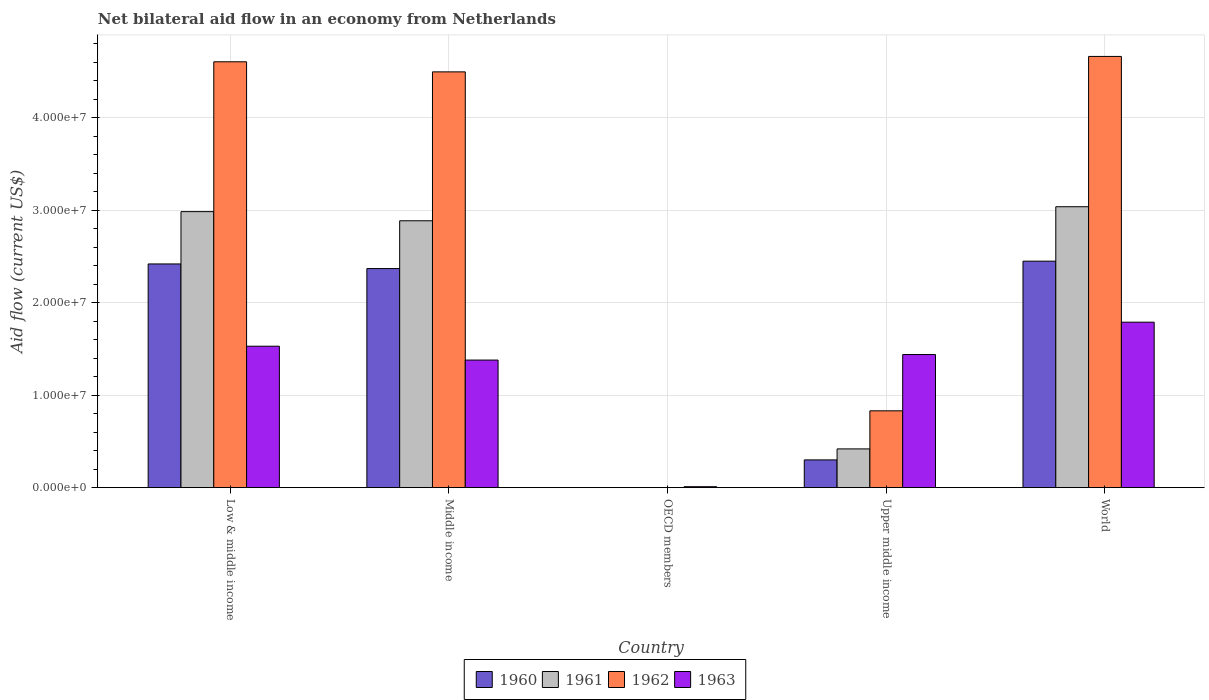How many bars are there on the 4th tick from the left?
Keep it short and to the point. 4. How many bars are there on the 4th tick from the right?
Ensure brevity in your answer.  4. What is the label of the 1st group of bars from the left?
Make the answer very short. Low & middle income. In how many cases, is the number of bars for a given country not equal to the number of legend labels?
Your answer should be compact. 1. What is the net bilateral aid flow in 1961 in Middle income?
Provide a succinct answer. 2.89e+07. Across all countries, what is the maximum net bilateral aid flow in 1960?
Provide a succinct answer. 2.45e+07. What is the total net bilateral aid flow in 1960 in the graph?
Offer a very short reply. 7.54e+07. What is the difference between the net bilateral aid flow in 1963 in OECD members and that in World?
Your answer should be very brief. -1.78e+07. What is the difference between the net bilateral aid flow in 1961 in Low & middle income and the net bilateral aid flow in 1960 in Upper middle income?
Your answer should be compact. 2.69e+07. What is the average net bilateral aid flow in 1960 per country?
Your response must be concise. 1.51e+07. What is the difference between the net bilateral aid flow of/in 1962 and net bilateral aid flow of/in 1961 in Low & middle income?
Your response must be concise. 1.62e+07. In how many countries, is the net bilateral aid flow in 1963 greater than 40000000 US$?
Provide a short and direct response. 0. What is the ratio of the net bilateral aid flow in 1962 in Middle income to that in World?
Give a very brief answer. 0.96. Is the net bilateral aid flow in 1961 in Low & middle income less than that in Upper middle income?
Give a very brief answer. No. What is the difference between the highest and the second highest net bilateral aid flow in 1961?
Keep it short and to the point. 1.52e+06. What is the difference between the highest and the lowest net bilateral aid flow in 1961?
Keep it short and to the point. 3.04e+07. Is it the case that in every country, the sum of the net bilateral aid flow in 1961 and net bilateral aid flow in 1962 is greater than the net bilateral aid flow in 1963?
Make the answer very short. No. How many bars are there?
Ensure brevity in your answer.  17. How many countries are there in the graph?
Keep it short and to the point. 5. What is the difference between two consecutive major ticks on the Y-axis?
Give a very brief answer. 1.00e+07. Does the graph contain any zero values?
Provide a succinct answer. Yes. How many legend labels are there?
Provide a succinct answer. 4. What is the title of the graph?
Ensure brevity in your answer.  Net bilateral aid flow in an economy from Netherlands. What is the label or title of the Y-axis?
Give a very brief answer. Aid flow (current US$). What is the Aid flow (current US$) of 1960 in Low & middle income?
Give a very brief answer. 2.42e+07. What is the Aid flow (current US$) in 1961 in Low & middle income?
Provide a short and direct response. 2.99e+07. What is the Aid flow (current US$) in 1962 in Low & middle income?
Provide a short and direct response. 4.61e+07. What is the Aid flow (current US$) of 1963 in Low & middle income?
Offer a very short reply. 1.53e+07. What is the Aid flow (current US$) of 1960 in Middle income?
Provide a short and direct response. 2.37e+07. What is the Aid flow (current US$) of 1961 in Middle income?
Your answer should be compact. 2.89e+07. What is the Aid flow (current US$) in 1962 in Middle income?
Make the answer very short. 4.50e+07. What is the Aid flow (current US$) of 1963 in Middle income?
Provide a succinct answer. 1.38e+07. What is the Aid flow (current US$) in 1961 in OECD members?
Give a very brief answer. 0. What is the Aid flow (current US$) of 1963 in OECD members?
Provide a succinct answer. 1.00e+05. What is the Aid flow (current US$) in 1960 in Upper middle income?
Make the answer very short. 3.00e+06. What is the Aid flow (current US$) in 1961 in Upper middle income?
Provide a short and direct response. 4.19e+06. What is the Aid flow (current US$) in 1962 in Upper middle income?
Provide a succinct answer. 8.31e+06. What is the Aid flow (current US$) of 1963 in Upper middle income?
Your answer should be compact. 1.44e+07. What is the Aid flow (current US$) in 1960 in World?
Your answer should be very brief. 2.45e+07. What is the Aid flow (current US$) in 1961 in World?
Offer a terse response. 3.04e+07. What is the Aid flow (current US$) of 1962 in World?
Make the answer very short. 4.66e+07. What is the Aid flow (current US$) in 1963 in World?
Your response must be concise. 1.79e+07. Across all countries, what is the maximum Aid flow (current US$) in 1960?
Offer a very short reply. 2.45e+07. Across all countries, what is the maximum Aid flow (current US$) of 1961?
Ensure brevity in your answer.  3.04e+07. Across all countries, what is the maximum Aid flow (current US$) in 1962?
Ensure brevity in your answer.  4.66e+07. Across all countries, what is the maximum Aid flow (current US$) of 1963?
Provide a succinct answer. 1.79e+07. Across all countries, what is the minimum Aid flow (current US$) in 1961?
Your answer should be compact. 0. What is the total Aid flow (current US$) of 1960 in the graph?
Provide a succinct answer. 7.54e+07. What is the total Aid flow (current US$) of 1961 in the graph?
Your answer should be compact. 9.33e+07. What is the total Aid flow (current US$) of 1962 in the graph?
Give a very brief answer. 1.46e+08. What is the total Aid flow (current US$) of 1963 in the graph?
Your answer should be very brief. 6.15e+07. What is the difference between the Aid flow (current US$) in 1961 in Low & middle income and that in Middle income?
Your response must be concise. 9.90e+05. What is the difference between the Aid flow (current US$) of 1962 in Low & middle income and that in Middle income?
Your answer should be compact. 1.09e+06. What is the difference between the Aid flow (current US$) of 1963 in Low & middle income and that in Middle income?
Make the answer very short. 1.50e+06. What is the difference between the Aid flow (current US$) in 1963 in Low & middle income and that in OECD members?
Your answer should be very brief. 1.52e+07. What is the difference between the Aid flow (current US$) of 1960 in Low & middle income and that in Upper middle income?
Your answer should be compact. 2.12e+07. What is the difference between the Aid flow (current US$) in 1961 in Low & middle income and that in Upper middle income?
Provide a succinct answer. 2.57e+07. What is the difference between the Aid flow (current US$) in 1962 in Low & middle income and that in Upper middle income?
Give a very brief answer. 3.78e+07. What is the difference between the Aid flow (current US$) of 1963 in Low & middle income and that in Upper middle income?
Offer a very short reply. 9.00e+05. What is the difference between the Aid flow (current US$) in 1960 in Low & middle income and that in World?
Offer a terse response. -3.00e+05. What is the difference between the Aid flow (current US$) of 1961 in Low & middle income and that in World?
Provide a short and direct response. -5.30e+05. What is the difference between the Aid flow (current US$) in 1962 in Low & middle income and that in World?
Give a very brief answer. -5.80e+05. What is the difference between the Aid flow (current US$) in 1963 in Low & middle income and that in World?
Offer a terse response. -2.60e+06. What is the difference between the Aid flow (current US$) in 1963 in Middle income and that in OECD members?
Make the answer very short. 1.37e+07. What is the difference between the Aid flow (current US$) of 1960 in Middle income and that in Upper middle income?
Make the answer very short. 2.07e+07. What is the difference between the Aid flow (current US$) of 1961 in Middle income and that in Upper middle income?
Provide a succinct answer. 2.47e+07. What is the difference between the Aid flow (current US$) of 1962 in Middle income and that in Upper middle income?
Offer a terse response. 3.67e+07. What is the difference between the Aid flow (current US$) of 1963 in Middle income and that in Upper middle income?
Provide a succinct answer. -6.00e+05. What is the difference between the Aid flow (current US$) of 1960 in Middle income and that in World?
Give a very brief answer. -8.00e+05. What is the difference between the Aid flow (current US$) of 1961 in Middle income and that in World?
Provide a succinct answer. -1.52e+06. What is the difference between the Aid flow (current US$) of 1962 in Middle income and that in World?
Make the answer very short. -1.67e+06. What is the difference between the Aid flow (current US$) in 1963 in Middle income and that in World?
Ensure brevity in your answer.  -4.10e+06. What is the difference between the Aid flow (current US$) of 1963 in OECD members and that in Upper middle income?
Give a very brief answer. -1.43e+07. What is the difference between the Aid flow (current US$) in 1963 in OECD members and that in World?
Offer a terse response. -1.78e+07. What is the difference between the Aid flow (current US$) in 1960 in Upper middle income and that in World?
Provide a short and direct response. -2.15e+07. What is the difference between the Aid flow (current US$) in 1961 in Upper middle income and that in World?
Your answer should be very brief. -2.62e+07. What is the difference between the Aid flow (current US$) of 1962 in Upper middle income and that in World?
Provide a short and direct response. -3.83e+07. What is the difference between the Aid flow (current US$) of 1963 in Upper middle income and that in World?
Make the answer very short. -3.50e+06. What is the difference between the Aid flow (current US$) in 1960 in Low & middle income and the Aid flow (current US$) in 1961 in Middle income?
Provide a short and direct response. -4.67e+06. What is the difference between the Aid flow (current US$) of 1960 in Low & middle income and the Aid flow (current US$) of 1962 in Middle income?
Ensure brevity in your answer.  -2.08e+07. What is the difference between the Aid flow (current US$) in 1960 in Low & middle income and the Aid flow (current US$) in 1963 in Middle income?
Your answer should be very brief. 1.04e+07. What is the difference between the Aid flow (current US$) of 1961 in Low & middle income and the Aid flow (current US$) of 1962 in Middle income?
Give a very brief answer. -1.51e+07. What is the difference between the Aid flow (current US$) in 1961 in Low & middle income and the Aid flow (current US$) in 1963 in Middle income?
Give a very brief answer. 1.61e+07. What is the difference between the Aid flow (current US$) of 1962 in Low & middle income and the Aid flow (current US$) of 1963 in Middle income?
Ensure brevity in your answer.  3.23e+07. What is the difference between the Aid flow (current US$) in 1960 in Low & middle income and the Aid flow (current US$) in 1963 in OECD members?
Keep it short and to the point. 2.41e+07. What is the difference between the Aid flow (current US$) in 1961 in Low & middle income and the Aid flow (current US$) in 1963 in OECD members?
Your response must be concise. 2.98e+07. What is the difference between the Aid flow (current US$) of 1962 in Low & middle income and the Aid flow (current US$) of 1963 in OECD members?
Your answer should be very brief. 4.60e+07. What is the difference between the Aid flow (current US$) of 1960 in Low & middle income and the Aid flow (current US$) of 1961 in Upper middle income?
Offer a very short reply. 2.00e+07. What is the difference between the Aid flow (current US$) of 1960 in Low & middle income and the Aid flow (current US$) of 1962 in Upper middle income?
Offer a terse response. 1.59e+07. What is the difference between the Aid flow (current US$) in 1960 in Low & middle income and the Aid flow (current US$) in 1963 in Upper middle income?
Offer a very short reply. 9.80e+06. What is the difference between the Aid flow (current US$) in 1961 in Low & middle income and the Aid flow (current US$) in 1962 in Upper middle income?
Give a very brief answer. 2.16e+07. What is the difference between the Aid flow (current US$) of 1961 in Low & middle income and the Aid flow (current US$) of 1963 in Upper middle income?
Ensure brevity in your answer.  1.55e+07. What is the difference between the Aid flow (current US$) in 1962 in Low & middle income and the Aid flow (current US$) in 1963 in Upper middle income?
Your answer should be compact. 3.17e+07. What is the difference between the Aid flow (current US$) of 1960 in Low & middle income and the Aid flow (current US$) of 1961 in World?
Keep it short and to the point. -6.19e+06. What is the difference between the Aid flow (current US$) of 1960 in Low & middle income and the Aid flow (current US$) of 1962 in World?
Your response must be concise. -2.24e+07. What is the difference between the Aid flow (current US$) in 1960 in Low & middle income and the Aid flow (current US$) in 1963 in World?
Ensure brevity in your answer.  6.30e+06. What is the difference between the Aid flow (current US$) of 1961 in Low & middle income and the Aid flow (current US$) of 1962 in World?
Your answer should be compact. -1.68e+07. What is the difference between the Aid flow (current US$) in 1961 in Low & middle income and the Aid flow (current US$) in 1963 in World?
Your answer should be compact. 1.20e+07. What is the difference between the Aid flow (current US$) in 1962 in Low & middle income and the Aid flow (current US$) in 1963 in World?
Give a very brief answer. 2.82e+07. What is the difference between the Aid flow (current US$) of 1960 in Middle income and the Aid flow (current US$) of 1963 in OECD members?
Your answer should be very brief. 2.36e+07. What is the difference between the Aid flow (current US$) in 1961 in Middle income and the Aid flow (current US$) in 1963 in OECD members?
Your response must be concise. 2.88e+07. What is the difference between the Aid flow (current US$) in 1962 in Middle income and the Aid flow (current US$) in 1963 in OECD members?
Ensure brevity in your answer.  4.49e+07. What is the difference between the Aid flow (current US$) in 1960 in Middle income and the Aid flow (current US$) in 1961 in Upper middle income?
Make the answer very short. 1.95e+07. What is the difference between the Aid flow (current US$) of 1960 in Middle income and the Aid flow (current US$) of 1962 in Upper middle income?
Give a very brief answer. 1.54e+07. What is the difference between the Aid flow (current US$) of 1960 in Middle income and the Aid flow (current US$) of 1963 in Upper middle income?
Keep it short and to the point. 9.30e+06. What is the difference between the Aid flow (current US$) in 1961 in Middle income and the Aid flow (current US$) in 1962 in Upper middle income?
Your response must be concise. 2.06e+07. What is the difference between the Aid flow (current US$) of 1961 in Middle income and the Aid flow (current US$) of 1963 in Upper middle income?
Ensure brevity in your answer.  1.45e+07. What is the difference between the Aid flow (current US$) in 1962 in Middle income and the Aid flow (current US$) in 1963 in Upper middle income?
Offer a terse response. 3.06e+07. What is the difference between the Aid flow (current US$) in 1960 in Middle income and the Aid flow (current US$) in 1961 in World?
Your answer should be compact. -6.69e+06. What is the difference between the Aid flow (current US$) in 1960 in Middle income and the Aid flow (current US$) in 1962 in World?
Offer a terse response. -2.30e+07. What is the difference between the Aid flow (current US$) of 1960 in Middle income and the Aid flow (current US$) of 1963 in World?
Provide a short and direct response. 5.80e+06. What is the difference between the Aid flow (current US$) in 1961 in Middle income and the Aid flow (current US$) in 1962 in World?
Provide a succinct answer. -1.78e+07. What is the difference between the Aid flow (current US$) of 1961 in Middle income and the Aid flow (current US$) of 1963 in World?
Your response must be concise. 1.10e+07. What is the difference between the Aid flow (current US$) of 1962 in Middle income and the Aid flow (current US$) of 1963 in World?
Provide a succinct answer. 2.71e+07. What is the difference between the Aid flow (current US$) in 1960 in Upper middle income and the Aid flow (current US$) in 1961 in World?
Provide a succinct answer. -2.74e+07. What is the difference between the Aid flow (current US$) of 1960 in Upper middle income and the Aid flow (current US$) of 1962 in World?
Your answer should be compact. -4.36e+07. What is the difference between the Aid flow (current US$) in 1960 in Upper middle income and the Aid flow (current US$) in 1963 in World?
Make the answer very short. -1.49e+07. What is the difference between the Aid flow (current US$) in 1961 in Upper middle income and the Aid flow (current US$) in 1962 in World?
Ensure brevity in your answer.  -4.25e+07. What is the difference between the Aid flow (current US$) of 1961 in Upper middle income and the Aid flow (current US$) of 1963 in World?
Your answer should be compact. -1.37e+07. What is the difference between the Aid flow (current US$) in 1962 in Upper middle income and the Aid flow (current US$) in 1963 in World?
Provide a short and direct response. -9.59e+06. What is the average Aid flow (current US$) of 1960 per country?
Offer a terse response. 1.51e+07. What is the average Aid flow (current US$) of 1961 per country?
Your answer should be compact. 1.87e+07. What is the average Aid flow (current US$) of 1962 per country?
Provide a succinct answer. 2.92e+07. What is the average Aid flow (current US$) in 1963 per country?
Your answer should be very brief. 1.23e+07. What is the difference between the Aid flow (current US$) in 1960 and Aid flow (current US$) in 1961 in Low & middle income?
Provide a short and direct response. -5.66e+06. What is the difference between the Aid flow (current US$) of 1960 and Aid flow (current US$) of 1962 in Low & middle income?
Your answer should be very brief. -2.19e+07. What is the difference between the Aid flow (current US$) of 1960 and Aid flow (current US$) of 1963 in Low & middle income?
Your answer should be compact. 8.90e+06. What is the difference between the Aid flow (current US$) in 1961 and Aid flow (current US$) in 1962 in Low & middle income?
Provide a succinct answer. -1.62e+07. What is the difference between the Aid flow (current US$) of 1961 and Aid flow (current US$) of 1963 in Low & middle income?
Keep it short and to the point. 1.46e+07. What is the difference between the Aid flow (current US$) of 1962 and Aid flow (current US$) of 1963 in Low & middle income?
Your answer should be very brief. 3.08e+07. What is the difference between the Aid flow (current US$) in 1960 and Aid flow (current US$) in 1961 in Middle income?
Your response must be concise. -5.17e+06. What is the difference between the Aid flow (current US$) in 1960 and Aid flow (current US$) in 1962 in Middle income?
Your response must be concise. -2.13e+07. What is the difference between the Aid flow (current US$) of 1960 and Aid flow (current US$) of 1963 in Middle income?
Keep it short and to the point. 9.90e+06. What is the difference between the Aid flow (current US$) of 1961 and Aid flow (current US$) of 1962 in Middle income?
Offer a very short reply. -1.61e+07. What is the difference between the Aid flow (current US$) of 1961 and Aid flow (current US$) of 1963 in Middle income?
Offer a terse response. 1.51e+07. What is the difference between the Aid flow (current US$) of 1962 and Aid flow (current US$) of 1963 in Middle income?
Give a very brief answer. 3.12e+07. What is the difference between the Aid flow (current US$) of 1960 and Aid flow (current US$) of 1961 in Upper middle income?
Your answer should be very brief. -1.19e+06. What is the difference between the Aid flow (current US$) of 1960 and Aid flow (current US$) of 1962 in Upper middle income?
Your answer should be very brief. -5.31e+06. What is the difference between the Aid flow (current US$) in 1960 and Aid flow (current US$) in 1963 in Upper middle income?
Offer a terse response. -1.14e+07. What is the difference between the Aid flow (current US$) in 1961 and Aid flow (current US$) in 1962 in Upper middle income?
Offer a very short reply. -4.12e+06. What is the difference between the Aid flow (current US$) of 1961 and Aid flow (current US$) of 1963 in Upper middle income?
Your answer should be compact. -1.02e+07. What is the difference between the Aid flow (current US$) of 1962 and Aid flow (current US$) of 1963 in Upper middle income?
Give a very brief answer. -6.09e+06. What is the difference between the Aid flow (current US$) in 1960 and Aid flow (current US$) in 1961 in World?
Your response must be concise. -5.89e+06. What is the difference between the Aid flow (current US$) in 1960 and Aid flow (current US$) in 1962 in World?
Your response must be concise. -2.22e+07. What is the difference between the Aid flow (current US$) in 1960 and Aid flow (current US$) in 1963 in World?
Provide a short and direct response. 6.60e+06. What is the difference between the Aid flow (current US$) of 1961 and Aid flow (current US$) of 1962 in World?
Make the answer very short. -1.63e+07. What is the difference between the Aid flow (current US$) of 1961 and Aid flow (current US$) of 1963 in World?
Offer a very short reply. 1.25e+07. What is the difference between the Aid flow (current US$) in 1962 and Aid flow (current US$) in 1963 in World?
Provide a succinct answer. 2.88e+07. What is the ratio of the Aid flow (current US$) of 1960 in Low & middle income to that in Middle income?
Offer a very short reply. 1.02. What is the ratio of the Aid flow (current US$) in 1961 in Low & middle income to that in Middle income?
Your answer should be compact. 1.03. What is the ratio of the Aid flow (current US$) in 1962 in Low & middle income to that in Middle income?
Ensure brevity in your answer.  1.02. What is the ratio of the Aid flow (current US$) in 1963 in Low & middle income to that in Middle income?
Your answer should be compact. 1.11. What is the ratio of the Aid flow (current US$) in 1963 in Low & middle income to that in OECD members?
Your answer should be compact. 153. What is the ratio of the Aid flow (current US$) in 1960 in Low & middle income to that in Upper middle income?
Offer a very short reply. 8.07. What is the ratio of the Aid flow (current US$) in 1961 in Low & middle income to that in Upper middle income?
Ensure brevity in your answer.  7.13. What is the ratio of the Aid flow (current US$) of 1962 in Low & middle income to that in Upper middle income?
Your answer should be compact. 5.54. What is the ratio of the Aid flow (current US$) in 1963 in Low & middle income to that in Upper middle income?
Your answer should be very brief. 1.06. What is the ratio of the Aid flow (current US$) of 1961 in Low & middle income to that in World?
Provide a short and direct response. 0.98. What is the ratio of the Aid flow (current US$) in 1962 in Low & middle income to that in World?
Offer a very short reply. 0.99. What is the ratio of the Aid flow (current US$) in 1963 in Low & middle income to that in World?
Offer a terse response. 0.85. What is the ratio of the Aid flow (current US$) of 1963 in Middle income to that in OECD members?
Offer a very short reply. 138. What is the ratio of the Aid flow (current US$) of 1961 in Middle income to that in Upper middle income?
Provide a succinct answer. 6.89. What is the ratio of the Aid flow (current US$) in 1962 in Middle income to that in Upper middle income?
Make the answer very short. 5.41. What is the ratio of the Aid flow (current US$) in 1960 in Middle income to that in World?
Provide a succinct answer. 0.97. What is the ratio of the Aid flow (current US$) of 1961 in Middle income to that in World?
Offer a very short reply. 0.95. What is the ratio of the Aid flow (current US$) of 1962 in Middle income to that in World?
Ensure brevity in your answer.  0.96. What is the ratio of the Aid flow (current US$) in 1963 in Middle income to that in World?
Offer a terse response. 0.77. What is the ratio of the Aid flow (current US$) of 1963 in OECD members to that in Upper middle income?
Keep it short and to the point. 0.01. What is the ratio of the Aid flow (current US$) of 1963 in OECD members to that in World?
Provide a succinct answer. 0.01. What is the ratio of the Aid flow (current US$) in 1960 in Upper middle income to that in World?
Offer a terse response. 0.12. What is the ratio of the Aid flow (current US$) of 1961 in Upper middle income to that in World?
Provide a short and direct response. 0.14. What is the ratio of the Aid flow (current US$) in 1962 in Upper middle income to that in World?
Offer a very short reply. 0.18. What is the ratio of the Aid flow (current US$) in 1963 in Upper middle income to that in World?
Give a very brief answer. 0.8. What is the difference between the highest and the second highest Aid flow (current US$) in 1960?
Offer a very short reply. 3.00e+05. What is the difference between the highest and the second highest Aid flow (current US$) of 1961?
Provide a succinct answer. 5.30e+05. What is the difference between the highest and the second highest Aid flow (current US$) in 1962?
Ensure brevity in your answer.  5.80e+05. What is the difference between the highest and the second highest Aid flow (current US$) in 1963?
Make the answer very short. 2.60e+06. What is the difference between the highest and the lowest Aid flow (current US$) in 1960?
Give a very brief answer. 2.45e+07. What is the difference between the highest and the lowest Aid flow (current US$) in 1961?
Make the answer very short. 3.04e+07. What is the difference between the highest and the lowest Aid flow (current US$) in 1962?
Offer a terse response. 4.66e+07. What is the difference between the highest and the lowest Aid flow (current US$) of 1963?
Give a very brief answer. 1.78e+07. 